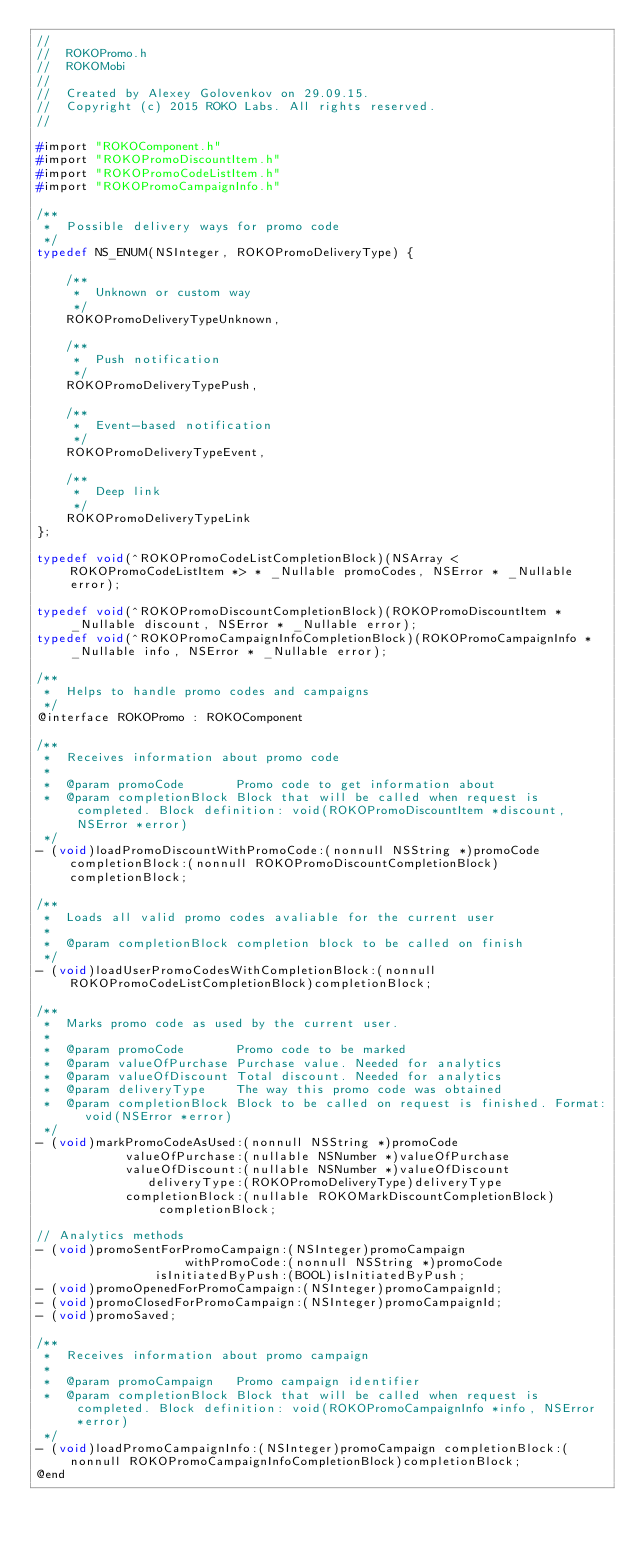Convert code to text. <code><loc_0><loc_0><loc_500><loc_500><_C_>//
//  ROKOPromo.h
//  ROKOMobi
//
//  Created by Alexey Golovenkov on 29.09.15.
//  Copyright (c) 2015 ROKO Labs. All rights reserved.
//

#import "ROKOComponent.h"
#import "ROKOPromoDiscountItem.h"
#import "ROKOPromoCodeListItem.h"
#import "ROKOPromoCampaignInfo.h"

/**
 *  Possible delivery ways for promo code
 */
typedef NS_ENUM(NSInteger, ROKOPromoDeliveryType) {
	
	/**
	 *  Unknown or custom way
	 */
	ROKOPromoDeliveryTypeUnknown,
	
	/**
	 *  Push notification
	 */
	ROKOPromoDeliveryTypePush,
	
	/**
	 *  Event-based notification
	 */
	ROKOPromoDeliveryTypeEvent,
	
	/**
	 *  Deep link
	 */
	ROKOPromoDeliveryTypeLink
};

typedef void(^ROKOPromoCodeListCompletionBlock)(NSArray <ROKOPromoCodeListItem *> * _Nullable promoCodes, NSError * _Nullable error);

typedef void(^ROKOPromoDiscountCompletionBlock)(ROKOPromoDiscountItem * _Nullable discount, NSError * _Nullable error);
typedef void(^ROKOPromoCampaignInfoCompletionBlock)(ROKOPromoCampaignInfo * _Nullable info, NSError * _Nullable error);

/**
 *  Helps to handle promo codes and campaigns
 */
@interface ROKOPromo : ROKOComponent

/**
 *  Receives information about promo code
 *
 *  @param promoCode       Promo code to get information about
 *  @param completionBlock Block that will be called when request is completed. Block definition: void(ROKOPromoDiscountItem *discount, NSError *error)
 */
- (void)loadPromoDiscountWithPromoCode:(nonnull NSString *)promoCode completionBlock:(nonnull ROKOPromoDiscountCompletionBlock)completionBlock;

/**
 *  Loads all valid promo codes avaliable for the current user
 *
 *  @param completionBlock completion block to be called on finish
 */
- (void)loadUserPromoCodesWithCompletionBlock:(nonnull ROKOPromoCodeListCompletionBlock)completionBlock;

/**
 *  Marks promo code as used by the current user.
 *
 *  @param promoCode       Promo code to be marked
 *  @param valueOfPurchase Purchase value. Needed for analytics
 *  @param valueOfDiscount Total discount. Needed for analytics
 *  @param deliveryType    The way this promo code was obtained
 *  @param completionBlock Block to be called on request is finished. Format: void(NSError *error)
 */
- (void)markPromoCodeAsUsed:(nonnull NSString *)promoCode
			valueOfPurchase:(nullable NSNumber *)valueOfPurchase
			valueOfDiscount:(nullable NSNumber *)valueOfDiscount
			   deliveryType:(ROKOPromoDeliveryType)deliveryType
			completionBlock:(nullable ROKOMarkDiscountCompletionBlock)completionBlock;

// Analytics methods
- (void)promoSentForPromoCampaign:(NSInteger)promoCampaign
					withPromoCode:(nonnull NSString *)promoCode
				isInitiatedByPush:(BOOL)isInitiatedByPush;
- (void)promoOpenedForPromoCampaign:(NSInteger)promoCampaignId;
- (void)promoClosedForPromoCampaign:(NSInteger)promoCampaignId;
- (void)promoSaved;

/**
 *  Receives information about promo campaign
 *
 *  @param promoCampaign   Promo campaign identifier
 *  @param completionBlock Block that will be called when request is completed. Block definition: void(ROKOPromoCampaignInfo *info, NSError *error)
 */
- (void)loadPromoCampaignInfo:(NSInteger)promoCampaign completionBlock:(nonnull ROKOPromoCampaignInfoCompletionBlock)completionBlock;
@end
</code> 